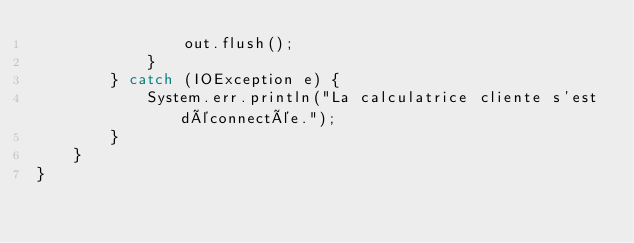<code> <loc_0><loc_0><loc_500><loc_500><_Java_>                out.flush();
            }
        } catch (IOException e) {
            System.err.println("La calculatrice cliente s'est déconnectée.");
        }
    }
}
</code> 